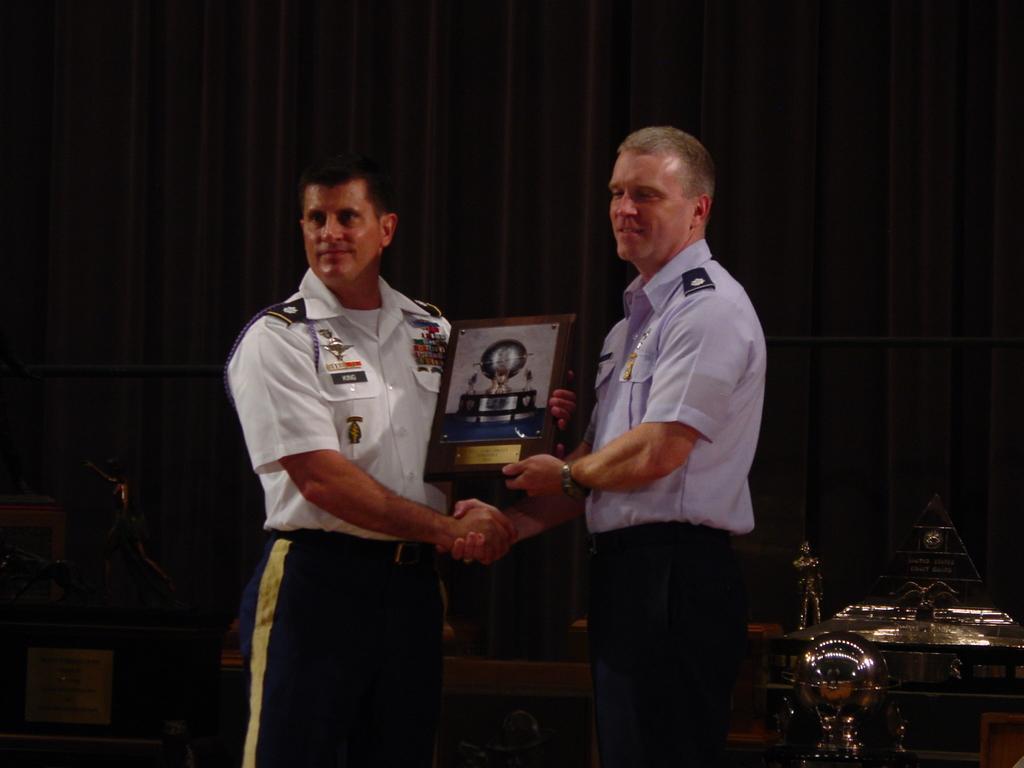Can you describe this image briefly? 2 men are standing holding a frame in their hand. Behind them there is are black curtains. 